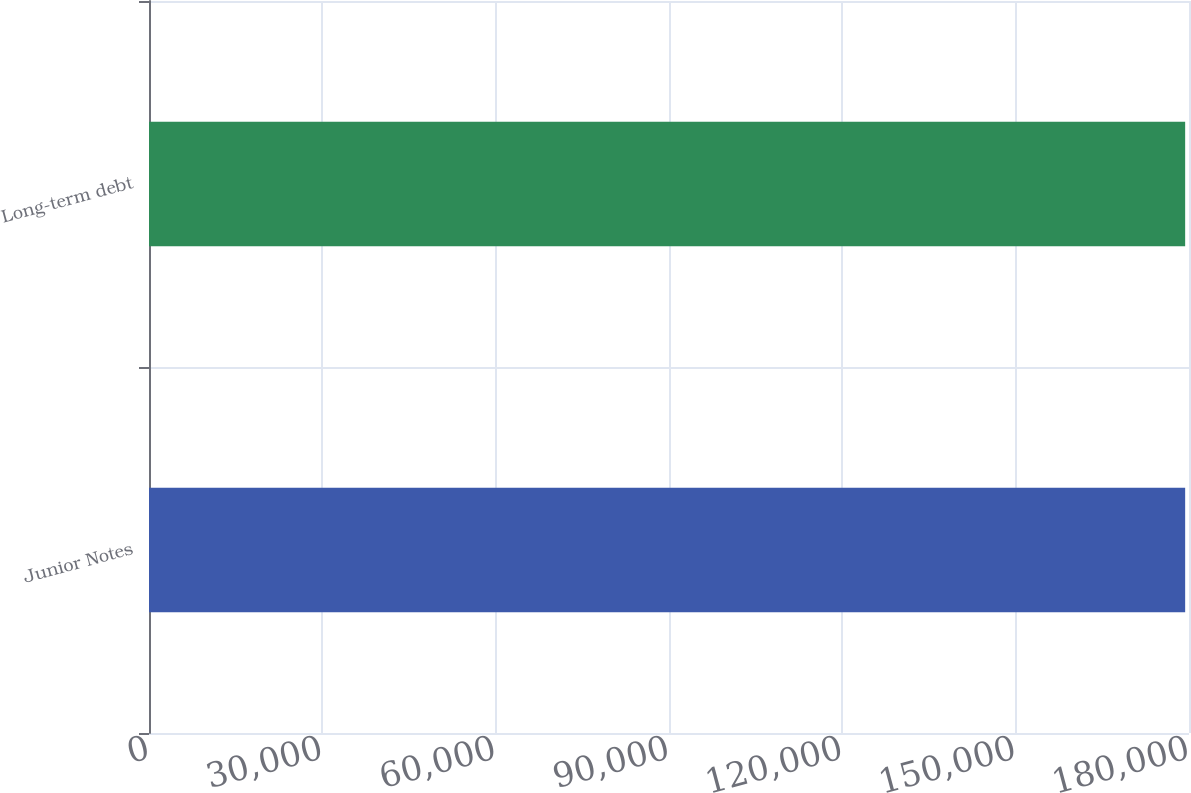Convert chart to OTSL. <chart><loc_0><loc_0><loc_500><loc_500><bar_chart><fcel>Junior Notes<fcel>Long-term debt<nl><fcel>179335<fcel>179335<nl></chart> 